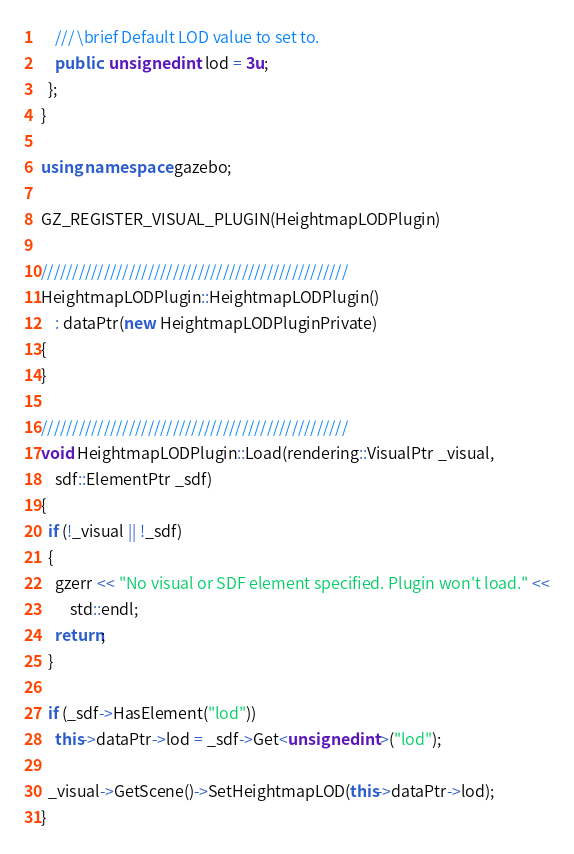Convert code to text. <code><loc_0><loc_0><loc_500><loc_500><_C++_>    /// \brief Default LOD value to set to.
    public: unsigned int lod = 3u;
  };
}

using namespace gazebo;

GZ_REGISTER_VISUAL_PLUGIN(HeightmapLODPlugin)

/////////////////////////////////////////////////
HeightmapLODPlugin::HeightmapLODPlugin()
    : dataPtr(new HeightmapLODPluginPrivate)
{
}

/////////////////////////////////////////////////
void HeightmapLODPlugin::Load(rendering::VisualPtr _visual,
    sdf::ElementPtr _sdf)
{
  if (!_visual || !_sdf)
  {
    gzerr << "No visual or SDF element specified. Plugin won't load." <<
        std::endl;
    return;
  }

  if (_sdf->HasElement("lod"))
    this->dataPtr->lod = _sdf->Get<unsigned int>("lod");

  _visual->GetScene()->SetHeightmapLOD(this->dataPtr->lod);
}
</code> 